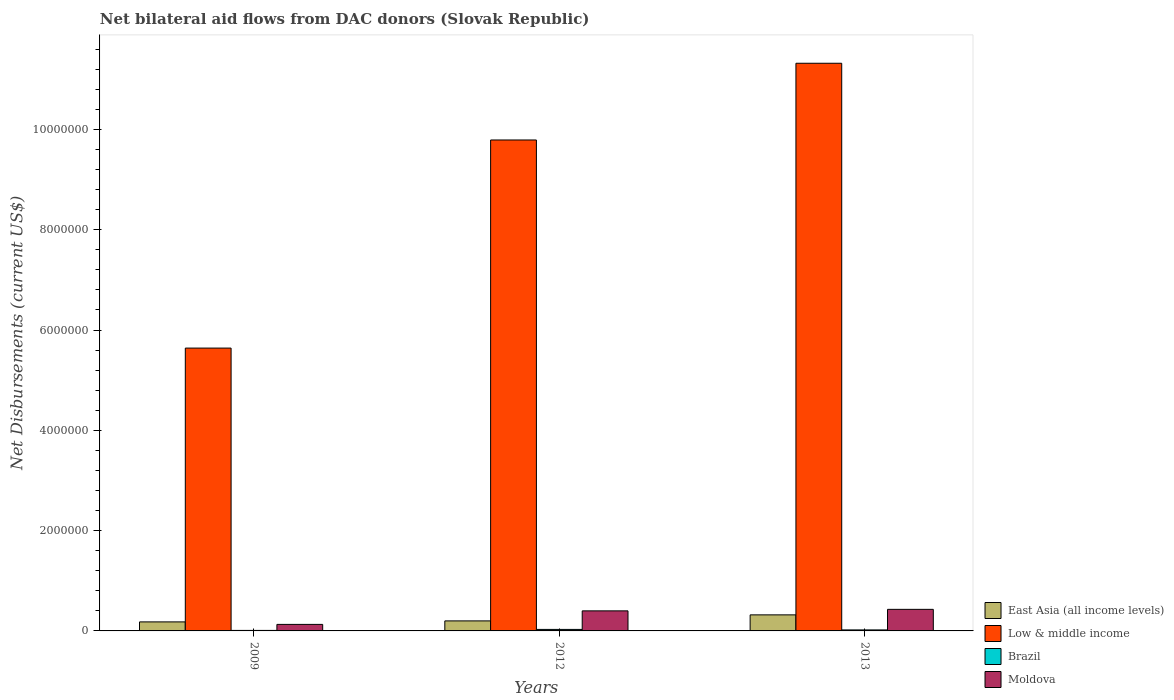How many different coloured bars are there?
Ensure brevity in your answer.  4. How many bars are there on the 3rd tick from the right?
Offer a very short reply. 4. What is the label of the 1st group of bars from the left?
Make the answer very short. 2009. Across all years, what is the maximum net bilateral aid flows in Low & middle income?
Ensure brevity in your answer.  1.13e+07. Across all years, what is the minimum net bilateral aid flows in East Asia (all income levels)?
Provide a short and direct response. 1.80e+05. In which year was the net bilateral aid flows in East Asia (all income levels) minimum?
Your answer should be compact. 2009. What is the difference between the net bilateral aid flows in Moldova in 2009 and that in 2012?
Give a very brief answer. -2.70e+05. What is the difference between the net bilateral aid flows in East Asia (all income levels) in 2009 and the net bilateral aid flows in Low & middle income in 2013?
Keep it short and to the point. -1.11e+07. What is the average net bilateral aid flows in Low & middle income per year?
Provide a short and direct response. 8.92e+06. In the year 2013, what is the difference between the net bilateral aid flows in East Asia (all income levels) and net bilateral aid flows in Low & middle income?
Offer a terse response. -1.10e+07. In how many years, is the net bilateral aid flows in East Asia (all income levels) greater than 5200000 US$?
Your answer should be very brief. 0. What is the ratio of the net bilateral aid flows in East Asia (all income levels) in 2009 to that in 2012?
Provide a succinct answer. 0.9. Is the net bilateral aid flows in Brazil in 2012 less than that in 2013?
Your answer should be compact. No. What is the difference between the highest and the second highest net bilateral aid flows in East Asia (all income levels)?
Your answer should be very brief. 1.20e+05. Is the sum of the net bilateral aid flows in Moldova in 2009 and 2012 greater than the maximum net bilateral aid flows in Brazil across all years?
Keep it short and to the point. Yes. Is it the case that in every year, the sum of the net bilateral aid flows in Moldova and net bilateral aid flows in Low & middle income is greater than the sum of net bilateral aid flows in East Asia (all income levels) and net bilateral aid flows in Brazil?
Your answer should be compact. No. What does the 4th bar from the left in 2012 represents?
Make the answer very short. Moldova. What does the 4th bar from the right in 2009 represents?
Your answer should be very brief. East Asia (all income levels). Is it the case that in every year, the sum of the net bilateral aid flows in Moldova and net bilateral aid flows in East Asia (all income levels) is greater than the net bilateral aid flows in Low & middle income?
Keep it short and to the point. No. Are all the bars in the graph horizontal?
Your answer should be very brief. No. How many years are there in the graph?
Make the answer very short. 3. What is the difference between two consecutive major ticks on the Y-axis?
Your response must be concise. 2.00e+06. Does the graph contain any zero values?
Make the answer very short. No. Where does the legend appear in the graph?
Offer a terse response. Bottom right. How are the legend labels stacked?
Your response must be concise. Vertical. What is the title of the graph?
Your answer should be very brief. Net bilateral aid flows from DAC donors (Slovak Republic). Does "Swaziland" appear as one of the legend labels in the graph?
Make the answer very short. No. What is the label or title of the X-axis?
Give a very brief answer. Years. What is the label or title of the Y-axis?
Provide a succinct answer. Net Disbursements (current US$). What is the Net Disbursements (current US$) in Low & middle income in 2009?
Offer a terse response. 5.64e+06. What is the Net Disbursements (current US$) in Brazil in 2009?
Offer a terse response. 10000. What is the Net Disbursements (current US$) in Moldova in 2009?
Make the answer very short. 1.30e+05. What is the Net Disbursements (current US$) of Low & middle income in 2012?
Give a very brief answer. 9.79e+06. What is the Net Disbursements (current US$) of Brazil in 2012?
Ensure brevity in your answer.  3.00e+04. What is the Net Disbursements (current US$) in Low & middle income in 2013?
Give a very brief answer. 1.13e+07. What is the Net Disbursements (current US$) in Brazil in 2013?
Ensure brevity in your answer.  2.00e+04. Across all years, what is the maximum Net Disbursements (current US$) in East Asia (all income levels)?
Provide a short and direct response. 3.20e+05. Across all years, what is the maximum Net Disbursements (current US$) of Low & middle income?
Your response must be concise. 1.13e+07. Across all years, what is the maximum Net Disbursements (current US$) in Moldova?
Your response must be concise. 4.30e+05. Across all years, what is the minimum Net Disbursements (current US$) of Low & middle income?
Your answer should be compact. 5.64e+06. Across all years, what is the minimum Net Disbursements (current US$) of Moldova?
Your response must be concise. 1.30e+05. What is the total Net Disbursements (current US$) in Low & middle income in the graph?
Your response must be concise. 2.68e+07. What is the total Net Disbursements (current US$) of Moldova in the graph?
Provide a succinct answer. 9.60e+05. What is the difference between the Net Disbursements (current US$) of Low & middle income in 2009 and that in 2012?
Provide a succinct answer. -4.15e+06. What is the difference between the Net Disbursements (current US$) of Moldova in 2009 and that in 2012?
Provide a succinct answer. -2.70e+05. What is the difference between the Net Disbursements (current US$) in Low & middle income in 2009 and that in 2013?
Provide a succinct answer. -5.68e+06. What is the difference between the Net Disbursements (current US$) of Brazil in 2009 and that in 2013?
Your response must be concise. -10000. What is the difference between the Net Disbursements (current US$) of Moldova in 2009 and that in 2013?
Offer a terse response. -3.00e+05. What is the difference between the Net Disbursements (current US$) of East Asia (all income levels) in 2012 and that in 2013?
Offer a very short reply. -1.20e+05. What is the difference between the Net Disbursements (current US$) of Low & middle income in 2012 and that in 2013?
Keep it short and to the point. -1.53e+06. What is the difference between the Net Disbursements (current US$) of Brazil in 2012 and that in 2013?
Offer a very short reply. 10000. What is the difference between the Net Disbursements (current US$) of Moldova in 2012 and that in 2013?
Give a very brief answer. -3.00e+04. What is the difference between the Net Disbursements (current US$) of East Asia (all income levels) in 2009 and the Net Disbursements (current US$) of Low & middle income in 2012?
Your response must be concise. -9.61e+06. What is the difference between the Net Disbursements (current US$) in East Asia (all income levels) in 2009 and the Net Disbursements (current US$) in Brazil in 2012?
Give a very brief answer. 1.50e+05. What is the difference between the Net Disbursements (current US$) of East Asia (all income levels) in 2009 and the Net Disbursements (current US$) of Moldova in 2012?
Provide a short and direct response. -2.20e+05. What is the difference between the Net Disbursements (current US$) in Low & middle income in 2009 and the Net Disbursements (current US$) in Brazil in 2012?
Keep it short and to the point. 5.61e+06. What is the difference between the Net Disbursements (current US$) of Low & middle income in 2009 and the Net Disbursements (current US$) of Moldova in 2012?
Offer a terse response. 5.24e+06. What is the difference between the Net Disbursements (current US$) of Brazil in 2009 and the Net Disbursements (current US$) of Moldova in 2012?
Make the answer very short. -3.90e+05. What is the difference between the Net Disbursements (current US$) of East Asia (all income levels) in 2009 and the Net Disbursements (current US$) of Low & middle income in 2013?
Provide a short and direct response. -1.11e+07. What is the difference between the Net Disbursements (current US$) in Low & middle income in 2009 and the Net Disbursements (current US$) in Brazil in 2013?
Give a very brief answer. 5.62e+06. What is the difference between the Net Disbursements (current US$) in Low & middle income in 2009 and the Net Disbursements (current US$) in Moldova in 2013?
Keep it short and to the point. 5.21e+06. What is the difference between the Net Disbursements (current US$) of Brazil in 2009 and the Net Disbursements (current US$) of Moldova in 2013?
Make the answer very short. -4.20e+05. What is the difference between the Net Disbursements (current US$) in East Asia (all income levels) in 2012 and the Net Disbursements (current US$) in Low & middle income in 2013?
Give a very brief answer. -1.11e+07. What is the difference between the Net Disbursements (current US$) in East Asia (all income levels) in 2012 and the Net Disbursements (current US$) in Moldova in 2013?
Your response must be concise. -2.30e+05. What is the difference between the Net Disbursements (current US$) in Low & middle income in 2012 and the Net Disbursements (current US$) in Brazil in 2013?
Your response must be concise. 9.77e+06. What is the difference between the Net Disbursements (current US$) in Low & middle income in 2012 and the Net Disbursements (current US$) in Moldova in 2013?
Your answer should be very brief. 9.36e+06. What is the difference between the Net Disbursements (current US$) in Brazil in 2012 and the Net Disbursements (current US$) in Moldova in 2013?
Offer a terse response. -4.00e+05. What is the average Net Disbursements (current US$) in East Asia (all income levels) per year?
Your answer should be very brief. 2.33e+05. What is the average Net Disbursements (current US$) in Low & middle income per year?
Your response must be concise. 8.92e+06. What is the average Net Disbursements (current US$) in Moldova per year?
Give a very brief answer. 3.20e+05. In the year 2009, what is the difference between the Net Disbursements (current US$) of East Asia (all income levels) and Net Disbursements (current US$) of Low & middle income?
Ensure brevity in your answer.  -5.46e+06. In the year 2009, what is the difference between the Net Disbursements (current US$) in Low & middle income and Net Disbursements (current US$) in Brazil?
Offer a very short reply. 5.63e+06. In the year 2009, what is the difference between the Net Disbursements (current US$) of Low & middle income and Net Disbursements (current US$) of Moldova?
Offer a very short reply. 5.51e+06. In the year 2012, what is the difference between the Net Disbursements (current US$) of East Asia (all income levels) and Net Disbursements (current US$) of Low & middle income?
Give a very brief answer. -9.59e+06. In the year 2012, what is the difference between the Net Disbursements (current US$) in East Asia (all income levels) and Net Disbursements (current US$) in Brazil?
Provide a succinct answer. 1.70e+05. In the year 2012, what is the difference between the Net Disbursements (current US$) of Low & middle income and Net Disbursements (current US$) of Brazil?
Keep it short and to the point. 9.76e+06. In the year 2012, what is the difference between the Net Disbursements (current US$) of Low & middle income and Net Disbursements (current US$) of Moldova?
Provide a succinct answer. 9.39e+06. In the year 2012, what is the difference between the Net Disbursements (current US$) in Brazil and Net Disbursements (current US$) in Moldova?
Ensure brevity in your answer.  -3.70e+05. In the year 2013, what is the difference between the Net Disbursements (current US$) in East Asia (all income levels) and Net Disbursements (current US$) in Low & middle income?
Offer a terse response. -1.10e+07. In the year 2013, what is the difference between the Net Disbursements (current US$) of East Asia (all income levels) and Net Disbursements (current US$) of Moldova?
Provide a short and direct response. -1.10e+05. In the year 2013, what is the difference between the Net Disbursements (current US$) of Low & middle income and Net Disbursements (current US$) of Brazil?
Provide a succinct answer. 1.13e+07. In the year 2013, what is the difference between the Net Disbursements (current US$) of Low & middle income and Net Disbursements (current US$) of Moldova?
Provide a succinct answer. 1.09e+07. In the year 2013, what is the difference between the Net Disbursements (current US$) of Brazil and Net Disbursements (current US$) of Moldova?
Provide a short and direct response. -4.10e+05. What is the ratio of the Net Disbursements (current US$) of Low & middle income in 2009 to that in 2012?
Provide a short and direct response. 0.58. What is the ratio of the Net Disbursements (current US$) in Brazil in 2009 to that in 2012?
Give a very brief answer. 0.33. What is the ratio of the Net Disbursements (current US$) in Moldova in 2009 to that in 2012?
Your answer should be very brief. 0.33. What is the ratio of the Net Disbursements (current US$) in East Asia (all income levels) in 2009 to that in 2013?
Provide a short and direct response. 0.56. What is the ratio of the Net Disbursements (current US$) in Low & middle income in 2009 to that in 2013?
Offer a very short reply. 0.5. What is the ratio of the Net Disbursements (current US$) of Moldova in 2009 to that in 2013?
Your answer should be very brief. 0.3. What is the ratio of the Net Disbursements (current US$) in East Asia (all income levels) in 2012 to that in 2013?
Give a very brief answer. 0.62. What is the ratio of the Net Disbursements (current US$) of Low & middle income in 2012 to that in 2013?
Keep it short and to the point. 0.86. What is the ratio of the Net Disbursements (current US$) in Moldova in 2012 to that in 2013?
Ensure brevity in your answer.  0.93. What is the difference between the highest and the second highest Net Disbursements (current US$) of Low & middle income?
Offer a very short reply. 1.53e+06. What is the difference between the highest and the second highest Net Disbursements (current US$) of Moldova?
Your answer should be very brief. 3.00e+04. What is the difference between the highest and the lowest Net Disbursements (current US$) in East Asia (all income levels)?
Your answer should be very brief. 1.40e+05. What is the difference between the highest and the lowest Net Disbursements (current US$) of Low & middle income?
Provide a short and direct response. 5.68e+06. What is the difference between the highest and the lowest Net Disbursements (current US$) in Moldova?
Offer a terse response. 3.00e+05. 